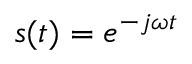Convert formula to latex. <formula><loc_0><loc_0><loc_500><loc_500>s ( t ) = e ^ { - j \omega t }</formula> 